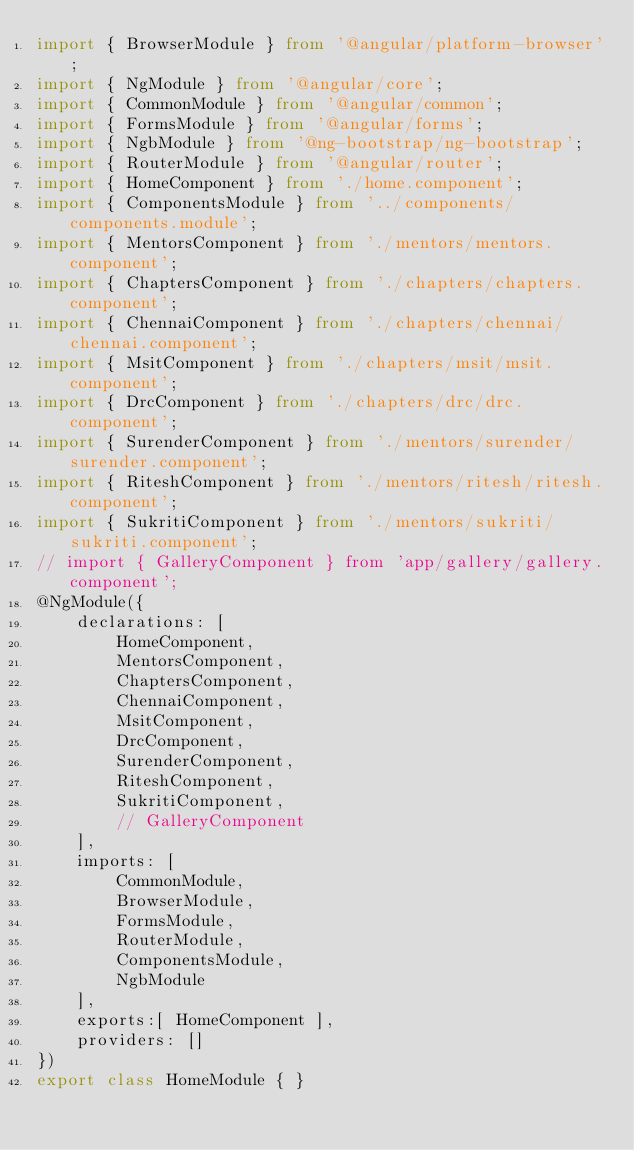Convert code to text. <code><loc_0><loc_0><loc_500><loc_500><_TypeScript_>import { BrowserModule } from '@angular/platform-browser';
import { NgModule } from '@angular/core';
import { CommonModule } from '@angular/common';
import { FormsModule } from '@angular/forms';
import { NgbModule } from '@ng-bootstrap/ng-bootstrap';
import { RouterModule } from '@angular/router';
import { HomeComponent } from './home.component';
import { ComponentsModule } from '../components/components.module';
import { MentorsComponent } from './mentors/mentors.component';
import { ChaptersComponent } from './chapters/chapters.component';
import { ChennaiComponent } from './chapters/chennai/chennai.component';
import { MsitComponent } from './chapters/msit/msit.component';
import { DrcComponent } from './chapters/drc/drc.component';
import { SurenderComponent } from './mentors/surender/surender.component';
import { RiteshComponent } from './mentors/ritesh/ritesh.component';
import { SukritiComponent } from './mentors/sukriti/sukriti.component';
// import { GalleryComponent } from 'app/gallery/gallery.component';
@NgModule({
    declarations: [
        HomeComponent,
        MentorsComponent,
        ChaptersComponent,
        ChennaiComponent,
        MsitComponent,
        DrcComponent,
        SurenderComponent,
        RiteshComponent,
        SukritiComponent,
        // GalleryComponent
    ],
    imports: [
        CommonModule,
        BrowserModule,
        FormsModule,
        RouterModule,
        ComponentsModule,
        NgbModule
    ],
    exports:[ HomeComponent ],
    providers: []
})
export class HomeModule { }
</code> 